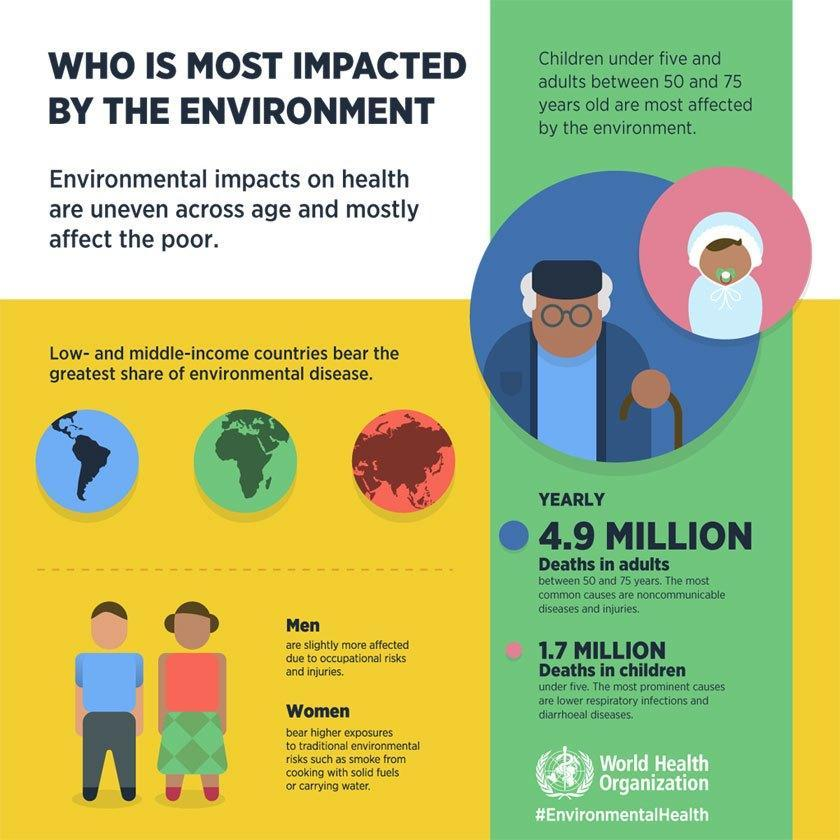who is more likely to be affected by environmental diseases - low income countries or high income countries?
Answer the question with a short phrase. low income countries which age group is more likely to be affected by environmental diseases - people of age between 50 and 60 or between 20 and 30? people of age between 50 and 60 who is more affected by the environmental diseases - men or women? men 